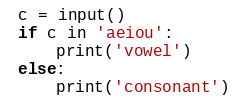Convert code to text. <code><loc_0><loc_0><loc_500><loc_500><_Python_>c = input()
if c in 'aeiou':
	print('vowel')
else:
	print('consonant')</code> 